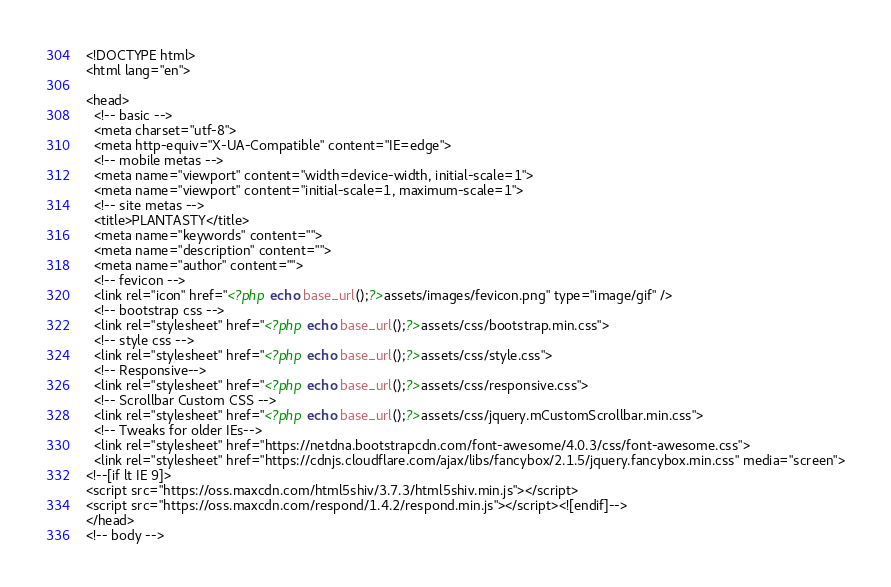<code> <loc_0><loc_0><loc_500><loc_500><_PHP_><!DOCTYPE html>
<html lang="en">

<head>
  <!-- basic -->
  <meta charset="utf-8">
  <meta http-equiv="X-UA-Compatible" content="IE=edge">
  <!-- mobile metas -->
  <meta name="viewport" content="width=device-width, initial-scale=1">
  <meta name="viewport" content="initial-scale=1, maximum-scale=1">
  <!-- site metas -->
  <title>PLANTASTY</title>
  <meta name="keywords" content="">
  <meta name="description" content="">
  <meta name="author" content="">
  <!-- fevicon -->
  <link rel="icon" href="<?php echo base_url();?>assets/images/fevicon.png" type="image/gif" />
  <!-- bootstrap css -->
  <link rel="stylesheet" href="<?php echo base_url();?>assets/css/bootstrap.min.css">
  <!-- style css -->
  <link rel="stylesheet" href="<?php echo base_url();?>assets/css/style.css">
  <!-- Responsive-->
  <link rel="stylesheet" href="<?php echo base_url();?>assets/css/responsive.css">  
  <!-- Scrollbar Custom CSS -->
  <link rel="stylesheet" href="<?php echo base_url();?>assets/css/jquery.mCustomScrollbar.min.css">
  <!-- Tweaks for older IEs-->
  <link rel="stylesheet" href="https://netdna.bootstrapcdn.com/font-awesome/4.0.3/css/font-awesome.css">
  <link rel="stylesheet" href="https://cdnjs.cloudflare.com/ajax/libs/fancybox/2.1.5/jquery.fancybox.min.css" media="screen">
<!--[if lt IE 9]>
<script src="https://oss.maxcdn.com/html5shiv/3.7.3/html5shiv.min.js"></script>
<script src="https://oss.maxcdn.com/respond/1.4.2/respond.min.js"></script><![endif]-->
</head>
<!-- body --></code> 